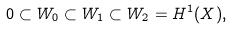Convert formula to latex. <formula><loc_0><loc_0><loc_500><loc_500>0 \subset W _ { 0 } \subset W _ { 1 } \subset W _ { 2 } = H ^ { 1 } ( X ) ,</formula> 